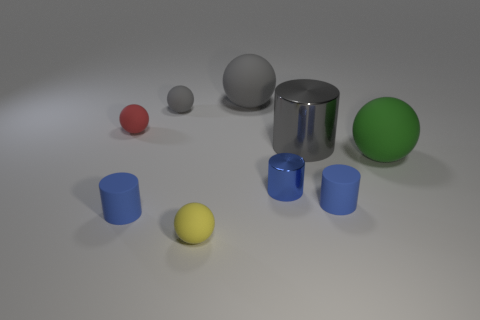How many other things are there of the same shape as the tiny gray object?
Provide a short and direct response. 4. How many other objects are the same size as the green matte object?
Provide a succinct answer. 2. There is a small rubber cylinder that is to the right of the yellow ball; is its color the same as the large metallic thing?
Provide a succinct answer. No. Is the number of red spheres right of the tiny metallic cylinder greater than the number of big cyan rubber balls?
Your answer should be compact. No. Are there any other things that have the same color as the large shiny cylinder?
Provide a succinct answer. Yes. The blue matte thing to the left of the big object left of the blue metal object is what shape?
Your answer should be very brief. Cylinder. Is the number of blue cylinders greater than the number of cyan cubes?
Provide a succinct answer. Yes. What number of balls are on the left side of the green sphere and on the right side of the big cylinder?
Your response must be concise. 0. What number of big spheres are left of the big sphere that is in front of the big gray metallic cylinder?
Ensure brevity in your answer.  1. What number of things are tiny cylinders left of the blue metal thing or matte spheres left of the yellow ball?
Your answer should be very brief. 3. 